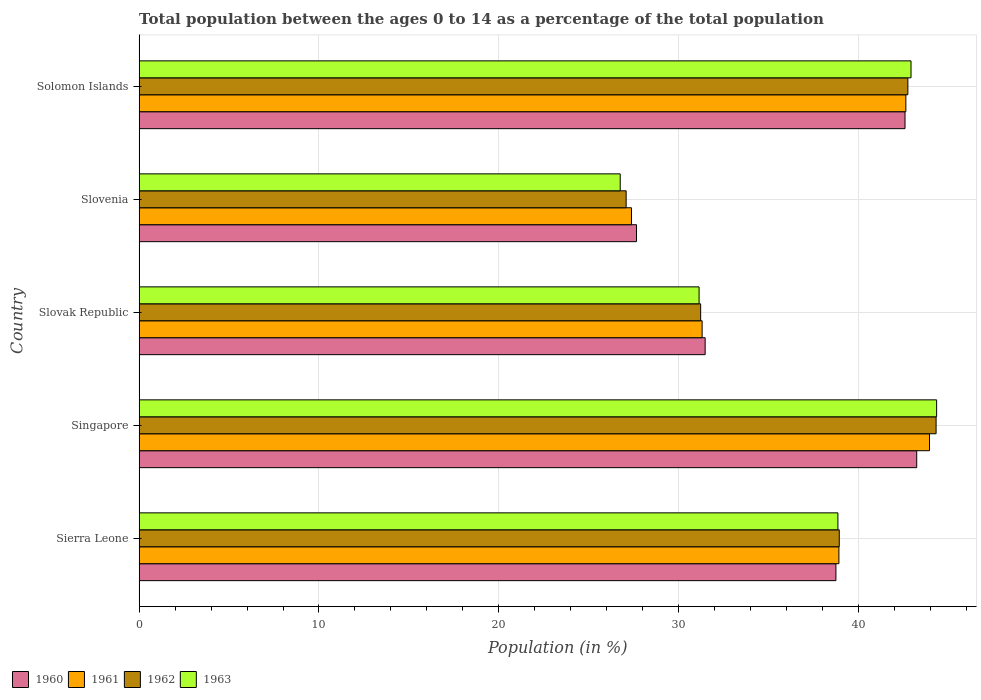How many different coloured bars are there?
Offer a terse response. 4. Are the number of bars on each tick of the Y-axis equal?
Your answer should be compact. Yes. How many bars are there on the 5th tick from the top?
Provide a succinct answer. 4. How many bars are there on the 4th tick from the bottom?
Make the answer very short. 4. What is the label of the 4th group of bars from the top?
Give a very brief answer. Singapore. What is the percentage of the population ages 0 to 14 in 1961 in Sierra Leone?
Your answer should be compact. 38.92. Across all countries, what is the maximum percentage of the population ages 0 to 14 in 1960?
Ensure brevity in your answer.  43.25. Across all countries, what is the minimum percentage of the population ages 0 to 14 in 1963?
Your answer should be very brief. 26.75. In which country was the percentage of the population ages 0 to 14 in 1960 maximum?
Offer a terse response. Singapore. In which country was the percentage of the population ages 0 to 14 in 1960 minimum?
Provide a succinct answer. Slovenia. What is the total percentage of the population ages 0 to 14 in 1962 in the graph?
Offer a very short reply. 184.33. What is the difference between the percentage of the population ages 0 to 14 in 1963 in Singapore and that in Solomon Islands?
Your answer should be compact. 1.42. What is the difference between the percentage of the population ages 0 to 14 in 1963 in Solomon Islands and the percentage of the population ages 0 to 14 in 1962 in Slovak Republic?
Offer a terse response. 11.7. What is the average percentage of the population ages 0 to 14 in 1960 per country?
Ensure brevity in your answer.  36.75. What is the difference between the percentage of the population ages 0 to 14 in 1960 and percentage of the population ages 0 to 14 in 1961 in Sierra Leone?
Offer a terse response. -0.17. In how many countries, is the percentage of the population ages 0 to 14 in 1961 greater than 22 ?
Your answer should be very brief. 5. What is the ratio of the percentage of the population ages 0 to 14 in 1960 in Sierra Leone to that in Singapore?
Make the answer very short. 0.9. Is the percentage of the population ages 0 to 14 in 1962 in Sierra Leone less than that in Slovak Republic?
Make the answer very short. No. Is the difference between the percentage of the population ages 0 to 14 in 1960 in Sierra Leone and Singapore greater than the difference between the percentage of the population ages 0 to 14 in 1961 in Sierra Leone and Singapore?
Your answer should be very brief. Yes. What is the difference between the highest and the second highest percentage of the population ages 0 to 14 in 1962?
Make the answer very short. 1.57. What is the difference between the highest and the lowest percentage of the population ages 0 to 14 in 1960?
Make the answer very short. 15.58. In how many countries, is the percentage of the population ages 0 to 14 in 1960 greater than the average percentage of the population ages 0 to 14 in 1960 taken over all countries?
Make the answer very short. 3. Is the sum of the percentage of the population ages 0 to 14 in 1962 in Sierra Leone and Slovenia greater than the maximum percentage of the population ages 0 to 14 in 1960 across all countries?
Your answer should be very brief. Yes. Is it the case that in every country, the sum of the percentage of the population ages 0 to 14 in 1962 and percentage of the population ages 0 to 14 in 1960 is greater than the percentage of the population ages 0 to 14 in 1961?
Ensure brevity in your answer.  Yes. How many bars are there?
Keep it short and to the point. 20. Are all the bars in the graph horizontal?
Ensure brevity in your answer.  Yes. What is the difference between two consecutive major ticks on the X-axis?
Your answer should be compact. 10. Are the values on the major ticks of X-axis written in scientific E-notation?
Your response must be concise. No. Does the graph contain grids?
Offer a terse response. Yes. Where does the legend appear in the graph?
Offer a very short reply. Bottom left. How many legend labels are there?
Give a very brief answer. 4. How are the legend labels stacked?
Offer a terse response. Horizontal. What is the title of the graph?
Give a very brief answer. Total population between the ages 0 to 14 as a percentage of the total population. Does "1975" appear as one of the legend labels in the graph?
Ensure brevity in your answer.  No. What is the label or title of the X-axis?
Give a very brief answer. Population (in %). What is the Population (in %) of 1960 in Sierra Leone?
Keep it short and to the point. 38.75. What is the Population (in %) in 1961 in Sierra Leone?
Provide a short and direct response. 38.92. What is the Population (in %) of 1962 in Sierra Leone?
Make the answer very short. 38.94. What is the Population (in %) in 1963 in Sierra Leone?
Provide a succinct answer. 38.86. What is the Population (in %) of 1960 in Singapore?
Offer a very short reply. 43.25. What is the Population (in %) of 1961 in Singapore?
Provide a succinct answer. 43.96. What is the Population (in %) in 1962 in Singapore?
Provide a succinct answer. 44.32. What is the Population (in %) of 1963 in Singapore?
Your answer should be compact. 44.35. What is the Population (in %) of 1960 in Slovak Republic?
Make the answer very short. 31.48. What is the Population (in %) of 1961 in Slovak Republic?
Ensure brevity in your answer.  31.31. What is the Population (in %) in 1962 in Slovak Republic?
Give a very brief answer. 31.23. What is the Population (in %) of 1963 in Slovak Republic?
Keep it short and to the point. 31.14. What is the Population (in %) in 1960 in Slovenia?
Keep it short and to the point. 27.66. What is the Population (in %) of 1961 in Slovenia?
Your answer should be very brief. 27.38. What is the Population (in %) of 1962 in Slovenia?
Provide a short and direct response. 27.08. What is the Population (in %) of 1963 in Slovenia?
Make the answer very short. 26.75. What is the Population (in %) of 1960 in Solomon Islands?
Give a very brief answer. 42.59. What is the Population (in %) of 1961 in Solomon Islands?
Offer a very short reply. 42.64. What is the Population (in %) of 1962 in Solomon Islands?
Offer a terse response. 42.75. What is the Population (in %) in 1963 in Solomon Islands?
Your answer should be very brief. 42.93. Across all countries, what is the maximum Population (in %) of 1960?
Ensure brevity in your answer.  43.25. Across all countries, what is the maximum Population (in %) in 1961?
Make the answer very short. 43.96. Across all countries, what is the maximum Population (in %) of 1962?
Give a very brief answer. 44.32. Across all countries, what is the maximum Population (in %) of 1963?
Make the answer very short. 44.35. Across all countries, what is the minimum Population (in %) of 1960?
Offer a terse response. 27.66. Across all countries, what is the minimum Population (in %) in 1961?
Provide a succinct answer. 27.38. Across all countries, what is the minimum Population (in %) in 1962?
Ensure brevity in your answer.  27.08. Across all countries, what is the minimum Population (in %) in 1963?
Offer a terse response. 26.75. What is the total Population (in %) of 1960 in the graph?
Your answer should be very brief. 183.73. What is the total Population (in %) of 1961 in the graph?
Your answer should be compact. 184.21. What is the total Population (in %) in 1962 in the graph?
Your response must be concise. 184.33. What is the total Population (in %) of 1963 in the graph?
Offer a terse response. 184.04. What is the difference between the Population (in %) in 1960 in Sierra Leone and that in Singapore?
Ensure brevity in your answer.  -4.49. What is the difference between the Population (in %) in 1961 in Sierra Leone and that in Singapore?
Ensure brevity in your answer.  -5.04. What is the difference between the Population (in %) of 1962 in Sierra Leone and that in Singapore?
Keep it short and to the point. -5.39. What is the difference between the Population (in %) of 1963 in Sierra Leone and that in Singapore?
Your answer should be compact. -5.49. What is the difference between the Population (in %) in 1960 in Sierra Leone and that in Slovak Republic?
Your response must be concise. 7.27. What is the difference between the Population (in %) in 1961 in Sierra Leone and that in Slovak Republic?
Your answer should be compact. 7.61. What is the difference between the Population (in %) in 1962 in Sierra Leone and that in Slovak Republic?
Offer a terse response. 7.71. What is the difference between the Population (in %) in 1963 in Sierra Leone and that in Slovak Republic?
Your response must be concise. 7.72. What is the difference between the Population (in %) in 1960 in Sierra Leone and that in Slovenia?
Provide a short and direct response. 11.09. What is the difference between the Population (in %) of 1961 in Sierra Leone and that in Slovenia?
Offer a terse response. 11.54. What is the difference between the Population (in %) of 1962 in Sierra Leone and that in Slovenia?
Offer a terse response. 11.85. What is the difference between the Population (in %) of 1963 in Sierra Leone and that in Slovenia?
Offer a very short reply. 12.11. What is the difference between the Population (in %) in 1960 in Sierra Leone and that in Solomon Islands?
Your answer should be compact. -3.84. What is the difference between the Population (in %) of 1961 in Sierra Leone and that in Solomon Islands?
Provide a short and direct response. -3.72. What is the difference between the Population (in %) in 1962 in Sierra Leone and that in Solomon Islands?
Offer a terse response. -3.82. What is the difference between the Population (in %) in 1963 in Sierra Leone and that in Solomon Islands?
Make the answer very short. -4.07. What is the difference between the Population (in %) in 1960 in Singapore and that in Slovak Republic?
Offer a terse response. 11.77. What is the difference between the Population (in %) of 1961 in Singapore and that in Slovak Republic?
Ensure brevity in your answer.  12.65. What is the difference between the Population (in %) of 1962 in Singapore and that in Slovak Republic?
Ensure brevity in your answer.  13.09. What is the difference between the Population (in %) of 1963 in Singapore and that in Slovak Republic?
Ensure brevity in your answer.  13.21. What is the difference between the Population (in %) in 1960 in Singapore and that in Slovenia?
Ensure brevity in your answer.  15.58. What is the difference between the Population (in %) in 1961 in Singapore and that in Slovenia?
Provide a short and direct response. 16.58. What is the difference between the Population (in %) of 1962 in Singapore and that in Slovenia?
Your response must be concise. 17.24. What is the difference between the Population (in %) of 1963 in Singapore and that in Slovenia?
Offer a very short reply. 17.6. What is the difference between the Population (in %) in 1960 in Singapore and that in Solomon Islands?
Offer a terse response. 0.65. What is the difference between the Population (in %) in 1961 in Singapore and that in Solomon Islands?
Your answer should be very brief. 1.31. What is the difference between the Population (in %) in 1962 in Singapore and that in Solomon Islands?
Make the answer very short. 1.57. What is the difference between the Population (in %) of 1963 in Singapore and that in Solomon Islands?
Make the answer very short. 1.42. What is the difference between the Population (in %) of 1960 in Slovak Republic and that in Slovenia?
Offer a terse response. 3.82. What is the difference between the Population (in %) in 1961 in Slovak Republic and that in Slovenia?
Provide a succinct answer. 3.93. What is the difference between the Population (in %) in 1962 in Slovak Republic and that in Slovenia?
Offer a very short reply. 4.14. What is the difference between the Population (in %) in 1963 in Slovak Republic and that in Slovenia?
Provide a succinct answer. 4.39. What is the difference between the Population (in %) in 1960 in Slovak Republic and that in Solomon Islands?
Your answer should be compact. -11.12. What is the difference between the Population (in %) in 1961 in Slovak Republic and that in Solomon Islands?
Offer a terse response. -11.33. What is the difference between the Population (in %) in 1962 in Slovak Republic and that in Solomon Islands?
Offer a very short reply. -11.52. What is the difference between the Population (in %) of 1963 in Slovak Republic and that in Solomon Islands?
Make the answer very short. -11.79. What is the difference between the Population (in %) in 1960 in Slovenia and that in Solomon Islands?
Provide a succinct answer. -14.93. What is the difference between the Population (in %) in 1961 in Slovenia and that in Solomon Islands?
Provide a short and direct response. -15.26. What is the difference between the Population (in %) of 1962 in Slovenia and that in Solomon Islands?
Make the answer very short. -15.67. What is the difference between the Population (in %) in 1963 in Slovenia and that in Solomon Islands?
Your answer should be very brief. -16.17. What is the difference between the Population (in %) of 1960 in Sierra Leone and the Population (in %) of 1961 in Singapore?
Provide a short and direct response. -5.2. What is the difference between the Population (in %) of 1960 in Sierra Leone and the Population (in %) of 1962 in Singapore?
Keep it short and to the point. -5.57. What is the difference between the Population (in %) of 1960 in Sierra Leone and the Population (in %) of 1963 in Singapore?
Your answer should be compact. -5.6. What is the difference between the Population (in %) of 1961 in Sierra Leone and the Population (in %) of 1962 in Singapore?
Give a very brief answer. -5.41. What is the difference between the Population (in %) in 1961 in Sierra Leone and the Population (in %) in 1963 in Singapore?
Your answer should be compact. -5.43. What is the difference between the Population (in %) of 1962 in Sierra Leone and the Population (in %) of 1963 in Singapore?
Ensure brevity in your answer.  -5.41. What is the difference between the Population (in %) of 1960 in Sierra Leone and the Population (in %) of 1961 in Slovak Republic?
Your answer should be compact. 7.44. What is the difference between the Population (in %) in 1960 in Sierra Leone and the Population (in %) in 1962 in Slovak Republic?
Make the answer very short. 7.52. What is the difference between the Population (in %) of 1960 in Sierra Leone and the Population (in %) of 1963 in Slovak Republic?
Offer a very short reply. 7.61. What is the difference between the Population (in %) in 1961 in Sierra Leone and the Population (in %) in 1962 in Slovak Republic?
Give a very brief answer. 7.69. What is the difference between the Population (in %) in 1961 in Sierra Leone and the Population (in %) in 1963 in Slovak Republic?
Your response must be concise. 7.78. What is the difference between the Population (in %) of 1962 in Sierra Leone and the Population (in %) of 1963 in Slovak Republic?
Keep it short and to the point. 7.8. What is the difference between the Population (in %) of 1960 in Sierra Leone and the Population (in %) of 1961 in Slovenia?
Offer a terse response. 11.37. What is the difference between the Population (in %) in 1960 in Sierra Leone and the Population (in %) in 1962 in Slovenia?
Your answer should be very brief. 11.67. What is the difference between the Population (in %) of 1960 in Sierra Leone and the Population (in %) of 1963 in Slovenia?
Your answer should be compact. 12. What is the difference between the Population (in %) of 1961 in Sierra Leone and the Population (in %) of 1962 in Slovenia?
Make the answer very short. 11.83. What is the difference between the Population (in %) of 1961 in Sierra Leone and the Population (in %) of 1963 in Slovenia?
Make the answer very short. 12.16. What is the difference between the Population (in %) of 1962 in Sierra Leone and the Population (in %) of 1963 in Slovenia?
Your answer should be compact. 12.18. What is the difference between the Population (in %) in 1960 in Sierra Leone and the Population (in %) in 1961 in Solomon Islands?
Your answer should be very brief. -3.89. What is the difference between the Population (in %) of 1960 in Sierra Leone and the Population (in %) of 1962 in Solomon Islands?
Your answer should be very brief. -4. What is the difference between the Population (in %) of 1960 in Sierra Leone and the Population (in %) of 1963 in Solomon Islands?
Your answer should be very brief. -4.18. What is the difference between the Population (in %) in 1961 in Sierra Leone and the Population (in %) in 1962 in Solomon Islands?
Make the answer very short. -3.83. What is the difference between the Population (in %) in 1961 in Sierra Leone and the Population (in %) in 1963 in Solomon Islands?
Offer a very short reply. -4.01. What is the difference between the Population (in %) of 1962 in Sierra Leone and the Population (in %) of 1963 in Solomon Islands?
Keep it short and to the point. -3.99. What is the difference between the Population (in %) in 1960 in Singapore and the Population (in %) in 1961 in Slovak Republic?
Offer a very short reply. 11.94. What is the difference between the Population (in %) in 1960 in Singapore and the Population (in %) in 1962 in Slovak Republic?
Offer a terse response. 12.02. What is the difference between the Population (in %) in 1960 in Singapore and the Population (in %) in 1963 in Slovak Republic?
Provide a short and direct response. 12.1. What is the difference between the Population (in %) in 1961 in Singapore and the Population (in %) in 1962 in Slovak Republic?
Ensure brevity in your answer.  12.73. What is the difference between the Population (in %) of 1961 in Singapore and the Population (in %) of 1963 in Slovak Republic?
Ensure brevity in your answer.  12.82. What is the difference between the Population (in %) in 1962 in Singapore and the Population (in %) in 1963 in Slovak Republic?
Provide a short and direct response. 13.18. What is the difference between the Population (in %) in 1960 in Singapore and the Population (in %) in 1961 in Slovenia?
Your answer should be compact. 15.86. What is the difference between the Population (in %) of 1960 in Singapore and the Population (in %) of 1962 in Slovenia?
Provide a short and direct response. 16.16. What is the difference between the Population (in %) of 1960 in Singapore and the Population (in %) of 1963 in Slovenia?
Provide a short and direct response. 16.49. What is the difference between the Population (in %) in 1961 in Singapore and the Population (in %) in 1962 in Slovenia?
Make the answer very short. 16.87. What is the difference between the Population (in %) in 1961 in Singapore and the Population (in %) in 1963 in Slovenia?
Keep it short and to the point. 17.2. What is the difference between the Population (in %) of 1962 in Singapore and the Population (in %) of 1963 in Slovenia?
Your answer should be very brief. 17.57. What is the difference between the Population (in %) of 1960 in Singapore and the Population (in %) of 1961 in Solomon Islands?
Provide a short and direct response. 0.6. What is the difference between the Population (in %) in 1960 in Singapore and the Population (in %) in 1962 in Solomon Islands?
Ensure brevity in your answer.  0.49. What is the difference between the Population (in %) of 1960 in Singapore and the Population (in %) of 1963 in Solomon Islands?
Your answer should be very brief. 0.32. What is the difference between the Population (in %) in 1961 in Singapore and the Population (in %) in 1962 in Solomon Islands?
Ensure brevity in your answer.  1.2. What is the difference between the Population (in %) in 1961 in Singapore and the Population (in %) in 1963 in Solomon Islands?
Provide a short and direct response. 1.03. What is the difference between the Population (in %) in 1962 in Singapore and the Population (in %) in 1963 in Solomon Islands?
Ensure brevity in your answer.  1.4. What is the difference between the Population (in %) of 1960 in Slovak Republic and the Population (in %) of 1961 in Slovenia?
Provide a short and direct response. 4.1. What is the difference between the Population (in %) in 1960 in Slovak Republic and the Population (in %) in 1962 in Slovenia?
Ensure brevity in your answer.  4.39. What is the difference between the Population (in %) of 1960 in Slovak Republic and the Population (in %) of 1963 in Slovenia?
Your answer should be compact. 4.72. What is the difference between the Population (in %) in 1961 in Slovak Republic and the Population (in %) in 1962 in Slovenia?
Provide a short and direct response. 4.23. What is the difference between the Population (in %) in 1961 in Slovak Republic and the Population (in %) in 1963 in Slovenia?
Offer a very short reply. 4.55. What is the difference between the Population (in %) of 1962 in Slovak Republic and the Population (in %) of 1963 in Slovenia?
Your response must be concise. 4.47. What is the difference between the Population (in %) in 1960 in Slovak Republic and the Population (in %) in 1961 in Solomon Islands?
Provide a short and direct response. -11.16. What is the difference between the Population (in %) of 1960 in Slovak Republic and the Population (in %) of 1962 in Solomon Islands?
Offer a very short reply. -11.27. What is the difference between the Population (in %) in 1960 in Slovak Republic and the Population (in %) in 1963 in Solomon Islands?
Your answer should be very brief. -11.45. What is the difference between the Population (in %) in 1961 in Slovak Republic and the Population (in %) in 1962 in Solomon Islands?
Your answer should be compact. -11.44. What is the difference between the Population (in %) in 1961 in Slovak Republic and the Population (in %) in 1963 in Solomon Islands?
Your answer should be very brief. -11.62. What is the difference between the Population (in %) of 1962 in Slovak Republic and the Population (in %) of 1963 in Solomon Islands?
Your answer should be compact. -11.7. What is the difference between the Population (in %) in 1960 in Slovenia and the Population (in %) in 1961 in Solomon Islands?
Keep it short and to the point. -14.98. What is the difference between the Population (in %) in 1960 in Slovenia and the Population (in %) in 1962 in Solomon Islands?
Your answer should be very brief. -15.09. What is the difference between the Population (in %) of 1960 in Slovenia and the Population (in %) of 1963 in Solomon Islands?
Your answer should be very brief. -15.27. What is the difference between the Population (in %) of 1961 in Slovenia and the Population (in %) of 1962 in Solomon Islands?
Keep it short and to the point. -15.37. What is the difference between the Population (in %) in 1961 in Slovenia and the Population (in %) in 1963 in Solomon Islands?
Provide a short and direct response. -15.55. What is the difference between the Population (in %) of 1962 in Slovenia and the Population (in %) of 1963 in Solomon Islands?
Your answer should be compact. -15.84. What is the average Population (in %) of 1960 per country?
Provide a short and direct response. 36.75. What is the average Population (in %) of 1961 per country?
Offer a very short reply. 36.84. What is the average Population (in %) of 1962 per country?
Offer a very short reply. 36.87. What is the average Population (in %) in 1963 per country?
Offer a very short reply. 36.81. What is the difference between the Population (in %) in 1960 and Population (in %) in 1961 in Sierra Leone?
Your answer should be very brief. -0.17. What is the difference between the Population (in %) in 1960 and Population (in %) in 1962 in Sierra Leone?
Provide a succinct answer. -0.19. What is the difference between the Population (in %) of 1960 and Population (in %) of 1963 in Sierra Leone?
Ensure brevity in your answer.  -0.11. What is the difference between the Population (in %) in 1961 and Population (in %) in 1962 in Sierra Leone?
Your answer should be very brief. -0.02. What is the difference between the Population (in %) in 1961 and Population (in %) in 1963 in Sierra Leone?
Your answer should be very brief. 0.06. What is the difference between the Population (in %) in 1962 and Population (in %) in 1963 in Sierra Leone?
Give a very brief answer. 0.08. What is the difference between the Population (in %) of 1960 and Population (in %) of 1961 in Singapore?
Your response must be concise. -0.71. What is the difference between the Population (in %) of 1960 and Population (in %) of 1962 in Singapore?
Provide a short and direct response. -1.08. What is the difference between the Population (in %) of 1960 and Population (in %) of 1963 in Singapore?
Make the answer very short. -1.11. What is the difference between the Population (in %) of 1961 and Population (in %) of 1962 in Singapore?
Offer a very short reply. -0.37. What is the difference between the Population (in %) in 1961 and Population (in %) in 1963 in Singapore?
Ensure brevity in your answer.  -0.4. What is the difference between the Population (in %) of 1962 and Population (in %) of 1963 in Singapore?
Your answer should be very brief. -0.03. What is the difference between the Population (in %) of 1960 and Population (in %) of 1961 in Slovak Republic?
Provide a short and direct response. 0.17. What is the difference between the Population (in %) of 1960 and Population (in %) of 1962 in Slovak Republic?
Your response must be concise. 0.25. What is the difference between the Population (in %) in 1960 and Population (in %) in 1963 in Slovak Republic?
Make the answer very short. 0.34. What is the difference between the Population (in %) in 1961 and Population (in %) in 1962 in Slovak Republic?
Ensure brevity in your answer.  0.08. What is the difference between the Population (in %) in 1961 and Population (in %) in 1963 in Slovak Republic?
Offer a very short reply. 0.17. What is the difference between the Population (in %) of 1962 and Population (in %) of 1963 in Slovak Republic?
Your answer should be very brief. 0.09. What is the difference between the Population (in %) in 1960 and Population (in %) in 1961 in Slovenia?
Provide a succinct answer. 0.28. What is the difference between the Population (in %) of 1960 and Population (in %) of 1962 in Slovenia?
Offer a very short reply. 0.58. What is the difference between the Population (in %) in 1960 and Population (in %) in 1963 in Slovenia?
Provide a succinct answer. 0.91. What is the difference between the Population (in %) in 1961 and Population (in %) in 1962 in Slovenia?
Give a very brief answer. 0.3. What is the difference between the Population (in %) in 1961 and Population (in %) in 1963 in Slovenia?
Offer a very short reply. 0.63. What is the difference between the Population (in %) of 1962 and Population (in %) of 1963 in Slovenia?
Your answer should be very brief. 0.33. What is the difference between the Population (in %) of 1960 and Population (in %) of 1961 in Solomon Islands?
Offer a very short reply. -0.05. What is the difference between the Population (in %) of 1960 and Population (in %) of 1962 in Solomon Islands?
Offer a terse response. -0.16. What is the difference between the Population (in %) of 1960 and Population (in %) of 1963 in Solomon Islands?
Offer a terse response. -0.33. What is the difference between the Population (in %) in 1961 and Population (in %) in 1962 in Solomon Islands?
Give a very brief answer. -0.11. What is the difference between the Population (in %) in 1961 and Population (in %) in 1963 in Solomon Islands?
Your response must be concise. -0.29. What is the difference between the Population (in %) in 1962 and Population (in %) in 1963 in Solomon Islands?
Provide a succinct answer. -0.17. What is the ratio of the Population (in %) of 1960 in Sierra Leone to that in Singapore?
Offer a terse response. 0.9. What is the ratio of the Population (in %) in 1961 in Sierra Leone to that in Singapore?
Offer a terse response. 0.89. What is the ratio of the Population (in %) in 1962 in Sierra Leone to that in Singapore?
Make the answer very short. 0.88. What is the ratio of the Population (in %) in 1963 in Sierra Leone to that in Singapore?
Make the answer very short. 0.88. What is the ratio of the Population (in %) in 1960 in Sierra Leone to that in Slovak Republic?
Provide a succinct answer. 1.23. What is the ratio of the Population (in %) in 1961 in Sierra Leone to that in Slovak Republic?
Make the answer very short. 1.24. What is the ratio of the Population (in %) in 1962 in Sierra Leone to that in Slovak Republic?
Make the answer very short. 1.25. What is the ratio of the Population (in %) in 1963 in Sierra Leone to that in Slovak Republic?
Offer a terse response. 1.25. What is the ratio of the Population (in %) of 1960 in Sierra Leone to that in Slovenia?
Your response must be concise. 1.4. What is the ratio of the Population (in %) in 1961 in Sierra Leone to that in Slovenia?
Ensure brevity in your answer.  1.42. What is the ratio of the Population (in %) of 1962 in Sierra Leone to that in Slovenia?
Give a very brief answer. 1.44. What is the ratio of the Population (in %) of 1963 in Sierra Leone to that in Slovenia?
Make the answer very short. 1.45. What is the ratio of the Population (in %) of 1960 in Sierra Leone to that in Solomon Islands?
Your response must be concise. 0.91. What is the ratio of the Population (in %) of 1961 in Sierra Leone to that in Solomon Islands?
Offer a terse response. 0.91. What is the ratio of the Population (in %) in 1962 in Sierra Leone to that in Solomon Islands?
Offer a terse response. 0.91. What is the ratio of the Population (in %) in 1963 in Sierra Leone to that in Solomon Islands?
Offer a terse response. 0.91. What is the ratio of the Population (in %) of 1960 in Singapore to that in Slovak Republic?
Keep it short and to the point. 1.37. What is the ratio of the Population (in %) of 1961 in Singapore to that in Slovak Republic?
Give a very brief answer. 1.4. What is the ratio of the Population (in %) of 1962 in Singapore to that in Slovak Republic?
Your answer should be very brief. 1.42. What is the ratio of the Population (in %) of 1963 in Singapore to that in Slovak Republic?
Keep it short and to the point. 1.42. What is the ratio of the Population (in %) in 1960 in Singapore to that in Slovenia?
Offer a terse response. 1.56. What is the ratio of the Population (in %) in 1961 in Singapore to that in Slovenia?
Your answer should be very brief. 1.61. What is the ratio of the Population (in %) of 1962 in Singapore to that in Slovenia?
Ensure brevity in your answer.  1.64. What is the ratio of the Population (in %) of 1963 in Singapore to that in Slovenia?
Make the answer very short. 1.66. What is the ratio of the Population (in %) in 1960 in Singapore to that in Solomon Islands?
Give a very brief answer. 1.02. What is the ratio of the Population (in %) in 1961 in Singapore to that in Solomon Islands?
Your answer should be very brief. 1.03. What is the ratio of the Population (in %) in 1962 in Singapore to that in Solomon Islands?
Offer a very short reply. 1.04. What is the ratio of the Population (in %) of 1963 in Singapore to that in Solomon Islands?
Make the answer very short. 1.03. What is the ratio of the Population (in %) in 1960 in Slovak Republic to that in Slovenia?
Your answer should be compact. 1.14. What is the ratio of the Population (in %) in 1961 in Slovak Republic to that in Slovenia?
Offer a terse response. 1.14. What is the ratio of the Population (in %) in 1962 in Slovak Republic to that in Slovenia?
Provide a short and direct response. 1.15. What is the ratio of the Population (in %) in 1963 in Slovak Republic to that in Slovenia?
Ensure brevity in your answer.  1.16. What is the ratio of the Population (in %) of 1960 in Slovak Republic to that in Solomon Islands?
Your answer should be compact. 0.74. What is the ratio of the Population (in %) in 1961 in Slovak Republic to that in Solomon Islands?
Make the answer very short. 0.73. What is the ratio of the Population (in %) of 1962 in Slovak Republic to that in Solomon Islands?
Provide a short and direct response. 0.73. What is the ratio of the Population (in %) in 1963 in Slovak Republic to that in Solomon Islands?
Give a very brief answer. 0.73. What is the ratio of the Population (in %) of 1960 in Slovenia to that in Solomon Islands?
Your response must be concise. 0.65. What is the ratio of the Population (in %) of 1961 in Slovenia to that in Solomon Islands?
Keep it short and to the point. 0.64. What is the ratio of the Population (in %) of 1962 in Slovenia to that in Solomon Islands?
Offer a terse response. 0.63. What is the ratio of the Population (in %) in 1963 in Slovenia to that in Solomon Islands?
Keep it short and to the point. 0.62. What is the difference between the highest and the second highest Population (in %) in 1960?
Provide a short and direct response. 0.65. What is the difference between the highest and the second highest Population (in %) in 1961?
Ensure brevity in your answer.  1.31. What is the difference between the highest and the second highest Population (in %) in 1962?
Your answer should be very brief. 1.57. What is the difference between the highest and the second highest Population (in %) in 1963?
Offer a very short reply. 1.42. What is the difference between the highest and the lowest Population (in %) in 1960?
Offer a very short reply. 15.58. What is the difference between the highest and the lowest Population (in %) in 1961?
Provide a short and direct response. 16.58. What is the difference between the highest and the lowest Population (in %) of 1962?
Make the answer very short. 17.24. What is the difference between the highest and the lowest Population (in %) in 1963?
Provide a succinct answer. 17.6. 